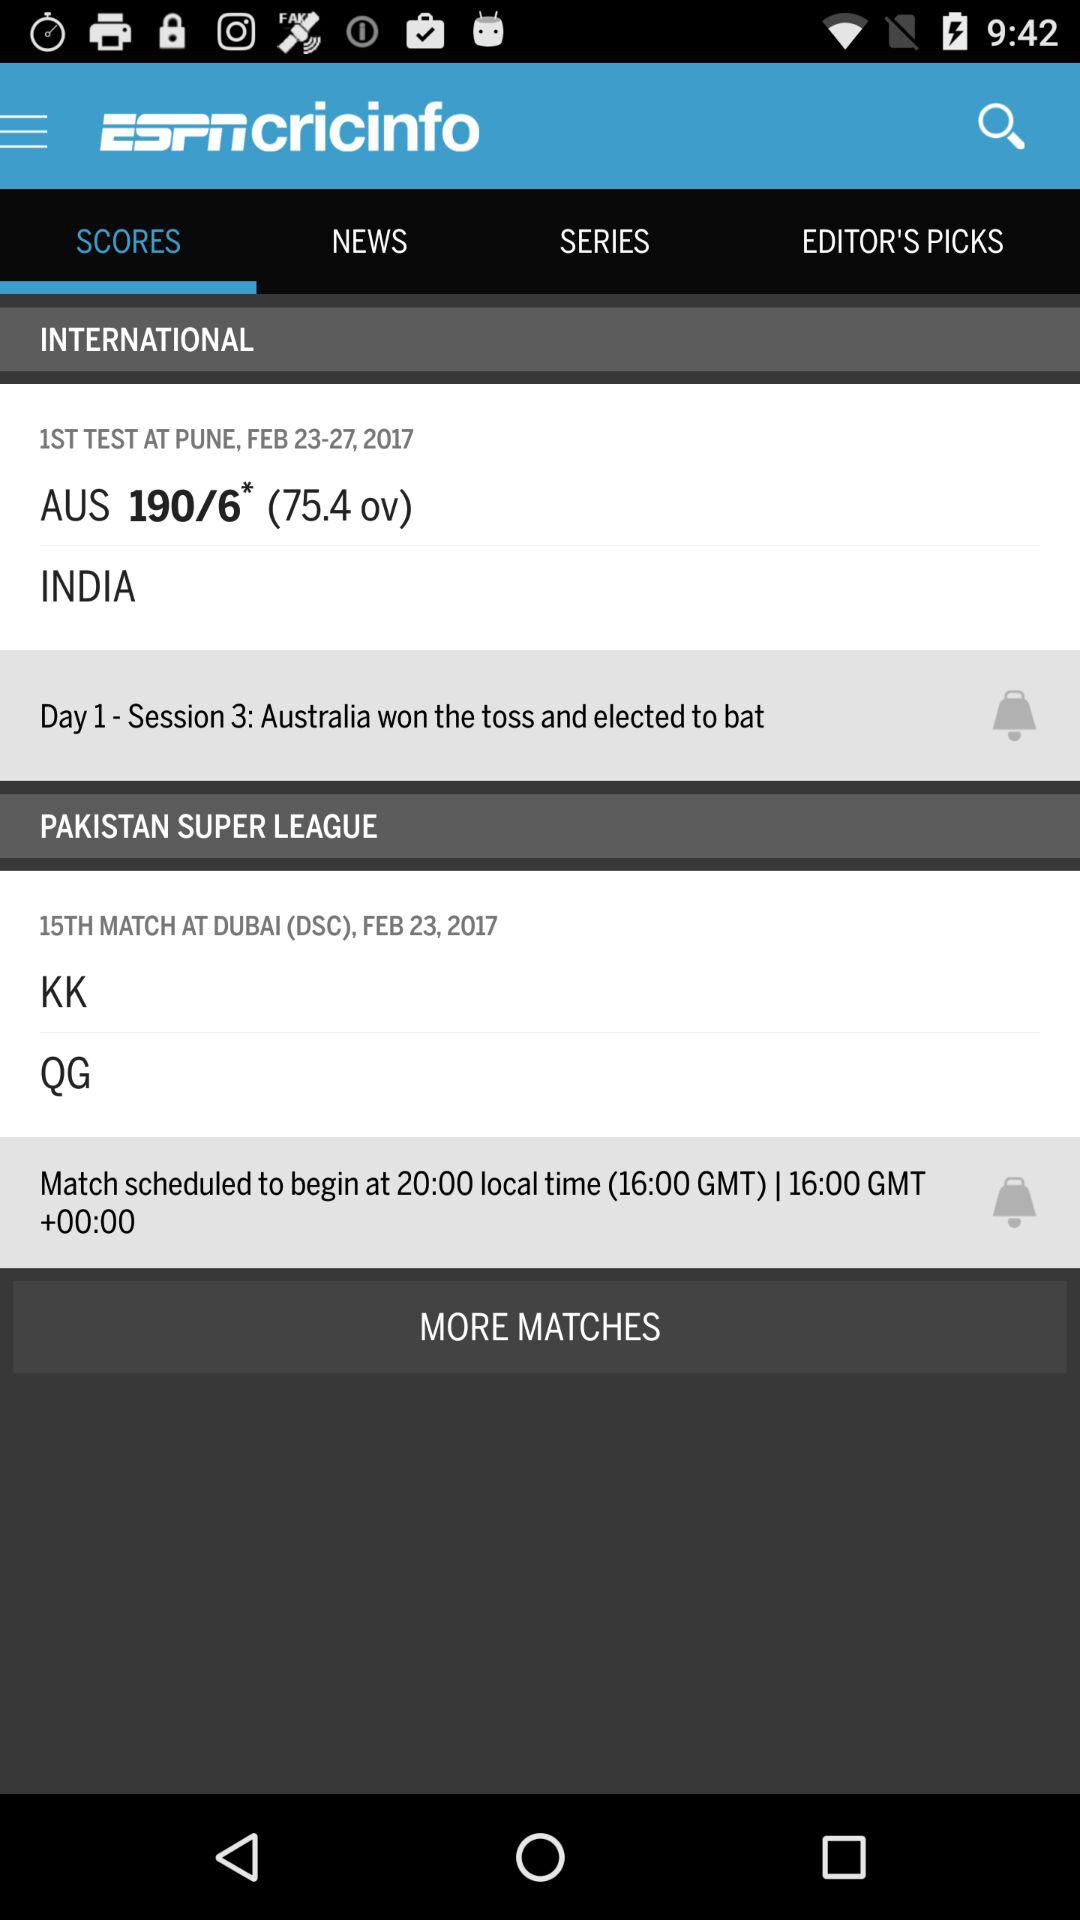At what time will the match between KK and QG start? The match between KK and QG will start at 16:00 GMT. 